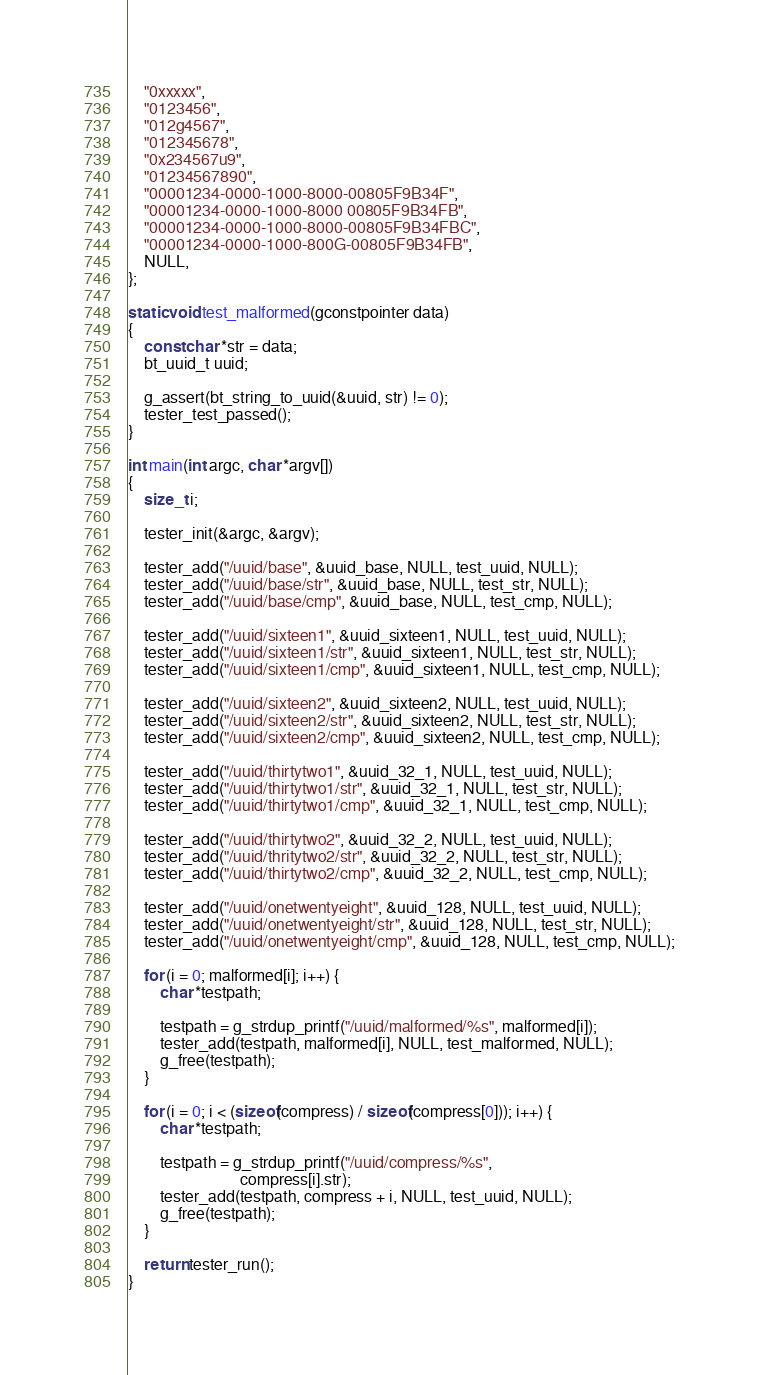Convert code to text. <code><loc_0><loc_0><loc_500><loc_500><_C_>	"0xxxxx",
	"0123456",
	"012g4567",
	"012345678",
	"0x234567u9",
	"01234567890",
	"00001234-0000-1000-8000-00805F9B34F",
	"00001234-0000-1000-8000 00805F9B34FB",
	"00001234-0000-1000-8000-00805F9B34FBC",
	"00001234-0000-1000-800G-00805F9B34FB",
	NULL,
};

static void test_malformed(gconstpointer data)
{
	const char *str = data;
	bt_uuid_t uuid;

	g_assert(bt_string_to_uuid(&uuid, str) != 0);
	tester_test_passed();
}

int main(int argc, char *argv[])
{
	size_t i;

	tester_init(&argc, &argv);

	tester_add("/uuid/base", &uuid_base, NULL, test_uuid, NULL);
	tester_add("/uuid/base/str", &uuid_base, NULL, test_str, NULL);
	tester_add("/uuid/base/cmp", &uuid_base, NULL, test_cmp, NULL);

	tester_add("/uuid/sixteen1", &uuid_sixteen1, NULL, test_uuid, NULL);
	tester_add("/uuid/sixteen1/str", &uuid_sixteen1, NULL, test_str, NULL);
	tester_add("/uuid/sixteen1/cmp", &uuid_sixteen1, NULL, test_cmp, NULL);

	tester_add("/uuid/sixteen2", &uuid_sixteen2, NULL, test_uuid, NULL);
	tester_add("/uuid/sixteen2/str", &uuid_sixteen2, NULL, test_str, NULL);
	tester_add("/uuid/sixteen2/cmp", &uuid_sixteen2, NULL, test_cmp, NULL);

	tester_add("/uuid/thirtytwo1", &uuid_32_1, NULL, test_uuid, NULL);
	tester_add("/uuid/thirtytwo1/str", &uuid_32_1, NULL, test_str, NULL);
	tester_add("/uuid/thirtytwo1/cmp", &uuid_32_1, NULL, test_cmp, NULL);

	tester_add("/uuid/thirtytwo2", &uuid_32_2, NULL, test_uuid, NULL);
	tester_add("/uuid/thritytwo2/str", &uuid_32_2, NULL, test_str, NULL);
	tester_add("/uuid/thirtytwo2/cmp", &uuid_32_2, NULL, test_cmp, NULL);

	tester_add("/uuid/onetwentyeight", &uuid_128, NULL, test_uuid, NULL);
	tester_add("/uuid/onetwentyeight/str", &uuid_128, NULL, test_str, NULL);
	tester_add("/uuid/onetwentyeight/cmp", &uuid_128, NULL, test_cmp, NULL);

	for (i = 0; malformed[i]; i++) {
		char *testpath;

		testpath = g_strdup_printf("/uuid/malformed/%s", malformed[i]);
		tester_add(testpath, malformed[i], NULL, test_malformed, NULL);
		g_free(testpath);
	}

	for (i = 0; i < (sizeof(compress) / sizeof(compress[0])); i++) {
		char *testpath;

		testpath = g_strdup_printf("/uuid/compress/%s",
							compress[i].str);
		tester_add(testpath, compress + i, NULL, test_uuid, NULL);
		g_free(testpath);
	}

	return tester_run();
}
</code> 